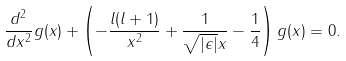Convert formula to latex. <formula><loc_0><loc_0><loc_500><loc_500>\frac { d ^ { 2 } } { d x ^ { 2 } } g ( x ) + \left ( - \frac { l ( l + 1 ) } { x ^ { 2 } } + \frac { 1 } { \sqrt { | \epsilon | } x } - \frac { 1 } { 4 } \right ) g ( x ) = 0 .</formula> 